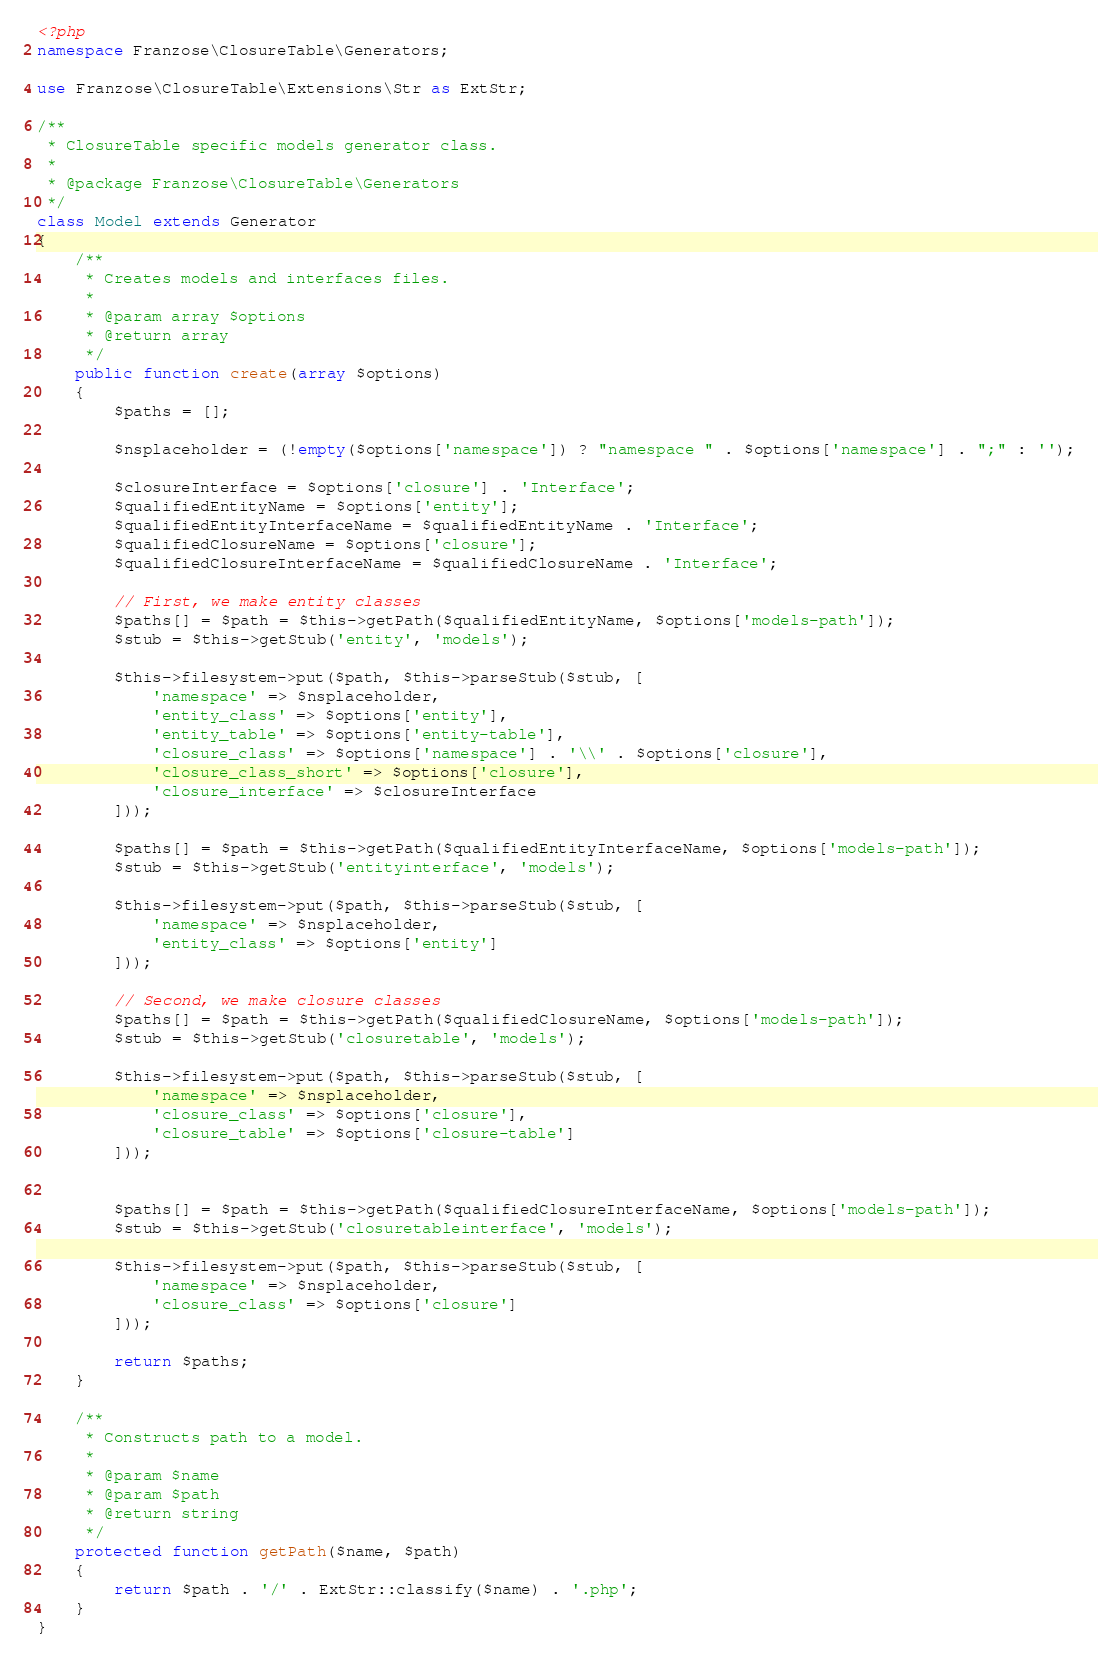<code> <loc_0><loc_0><loc_500><loc_500><_PHP_><?php
namespace Franzose\ClosureTable\Generators;

use Franzose\ClosureTable\Extensions\Str as ExtStr;

/**
 * ClosureTable specific models generator class.
 *
 * @package Franzose\ClosureTable\Generators
 */
class Model extends Generator
{
    /**
     * Creates models and interfaces files.
     *
     * @param array $options
     * @return array
     */
    public function create(array $options)
    {
        $paths = [];

        $nsplaceholder = (!empty($options['namespace']) ? "namespace " . $options['namespace'] . ";" : '');

        $closureInterface = $options['closure'] . 'Interface';
        $qualifiedEntityName = $options['entity'];
        $qualifiedEntityInterfaceName = $qualifiedEntityName . 'Interface';
        $qualifiedClosureName = $options['closure'];
        $qualifiedClosureInterfaceName = $qualifiedClosureName . 'Interface';

        // First, we make entity classes
        $paths[] = $path = $this->getPath($qualifiedEntityName, $options['models-path']);
        $stub = $this->getStub('entity', 'models');

        $this->filesystem->put($path, $this->parseStub($stub, [
            'namespace' => $nsplaceholder,
            'entity_class' => $options['entity'],
            'entity_table' => $options['entity-table'],
            'closure_class' => $options['namespace'] . '\\' . $options['closure'],
            'closure_class_short' => $options['closure'],
            'closure_interface' => $closureInterface
        ]));

        $paths[] = $path = $this->getPath($qualifiedEntityInterfaceName, $options['models-path']);
        $stub = $this->getStub('entityinterface', 'models');

        $this->filesystem->put($path, $this->parseStub($stub, [
            'namespace' => $nsplaceholder,
            'entity_class' => $options['entity']
        ]));

        // Second, we make closure classes
        $paths[] = $path = $this->getPath($qualifiedClosureName, $options['models-path']);
        $stub = $this->getStub('closuretable', 'models');

        $this->filesystem->put($path, $this->parseStub($stub, [
            'namespace' => $nsplaceholder,
            'closure_class' => $options['closure'],
            'closure_table' => $options['closure-table']
        ]));


        $paths[] = $path = $this->getPath($qualifiedClosureInterfaceName, $options['models-path']);
        $stub = $this->getStub('closuretableinterface', 'models');

        $this->filesystem->put($path, $this->parseStub($stub, [
            'namespace' => $nsplaceholder,
            'closure_class' => $options['closure']
        ]));

        return $paths;
    }

    /**
     * Constructs path to a model.
     *
     * @param $name
     * @param $path
     * @return string
     */
    protected function getPath($name, $path)
    {
        return $path . '/' . ExtStr::classify($name) . '.php';
    }
}
</code> 